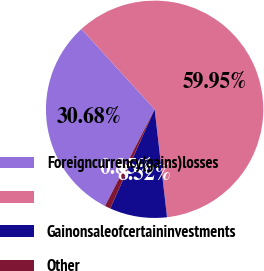Convert chart to OTSL. <chart><loc_0><loc_0><loc_500><loc_500><pie_chart><fcel>Foreigncurrency(gains)losses<fcel>Unnamed: 1<fcel>Gainonsaleofcertaininvestments<fcel>Other<nl><fcel>30.68%<fcel>59.94%<fcel>8.52%<fcel>0.85%<nl></chart> 